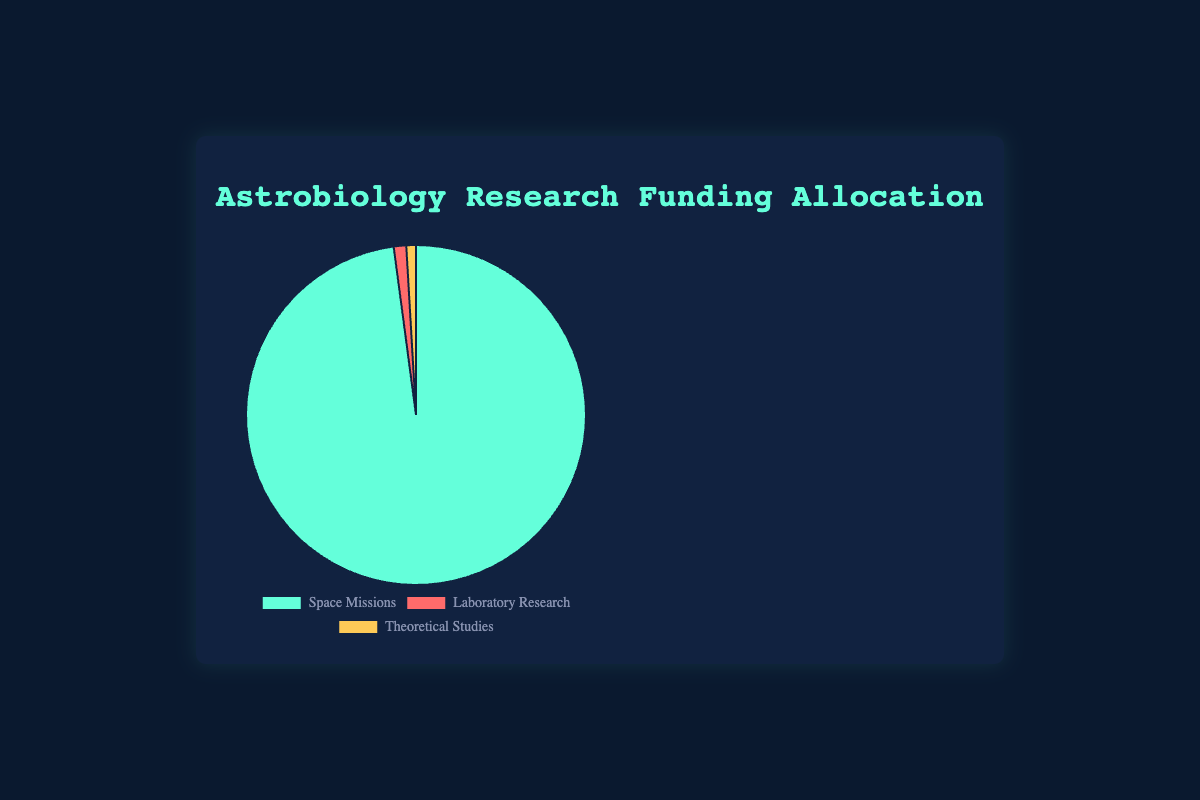What is the percentage allocation of funding for Space Missions? The data shows the funding for Space Missions is $17.1 billion. The total funding is $17.1 billion (Space Missions) + $0.207 billion (Laboratory Research) + $0.16 billion (Theoretical Studies) = $17.467 billion. The percentage is (17.1 / 17.467) * 100 ≈ 97.9%.
Answer: 97.9% How does the funding for Laboratory Research compare to the funding for Theoretical Studies? Laboratory Research has $207 million, while Theoretical Studies have $160 million. Therefore, Laboratory Research has more funding compared to Theoretical Studies by $207M - $160M = $47 million.
Answer: Laboratory Research has $47 million more funding than Theoretical Studies Which category receives the least amount of funding? By looking at the data, it's evident that Theoretical Studies receive $160 million, which is less than Laboratory Research ($207 million) and significantly less than Space Missions ($17.1 billion).
Answer: Theoretical Studies What is the difference in funding between Space Missions and the combined funding for Laboratory Research and Theoretical Studies? Space Missions have $17.1 billion. Combined funding for Laboratory Research and Theoretical Studies is $0.207 billion + $0.16 billion = $0.367 billion. The difference is $17.1 billion - $0.367 billion = $16.733 billion.
Answer: $16.733 billion What percentage of the total funding is allocated to Laboratory Research? Total funding is $17.467 billion. Laboratory Research receives $0.207 billion. The percentage is (0.207 / 17.467) * 100 ≈ 1.19%.
Answer: 1.19% Which category has the highest allocation and by how much compared to the second highest allocation? Space Missions have the highest allocation at $17.1 billion. The second highest is Laboratory Research with $0.207 billion. The difference is $17.1 billion - $0.207 billion = $16.893 billion.
Answer: Space Missions by $16.893 billion Calculate the average funding per project within Theoretical Studies. There are three projects in Theoretical Studies with a total funding of $160 million. The average is $160 million / 3 = approximately $53.33 million per project.
Answer: $53.33 million per project What color represents the category with the second-highest funding? From the visual attributes, Laboratory Research is represented by red, which comes second to the Space Missions’ green.
Answer: Red What is the combined total funding for all the categories? Summing up all the categories: $17.1 billion (Space Missions) + $0.207 billion (Laboratory Research) + $0.16 billion (Theoretical Studies) = $17.467 billion.
Answer: $17.467 billion 